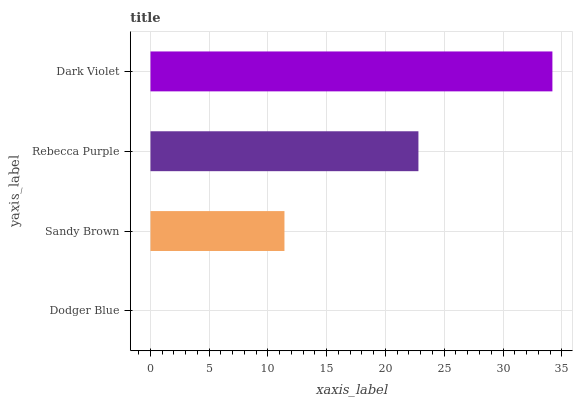Is Dodger Blue the minimum?
Answer yes or no. Yes. Is Dark Violet the maximum?
Answer yes or no. Yes. Is Sandy Brown the minimum?
Answer yes or no. No. Is Sandy Brown the maximum?
Answer yes or no. No. Is Sandy Brown greater than Dodger Blue?
Answer yes or no. Yes. Is Dodger Blue less than Sandy Brown?
Answer yes or no. Yes. Is Dodger Blue greater than Sandy Brown?
Answer yes or no. No. Is Sandy Brown less than Dodger Blue?
Answer yes or no. No. Is Rebecca Purple the high median?
Answer yes or no. Yes. Is Sandy Brown the low median?
Answer yes or no. Yes. Is Dark Violet the high median?
Answer yes or no. No. Is Dodger Blue the low median?
Answer yes or no. No. 